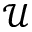<formula> <loc_0><loc_0><loc_500><loc_500>\mathcal { U }</formula> 